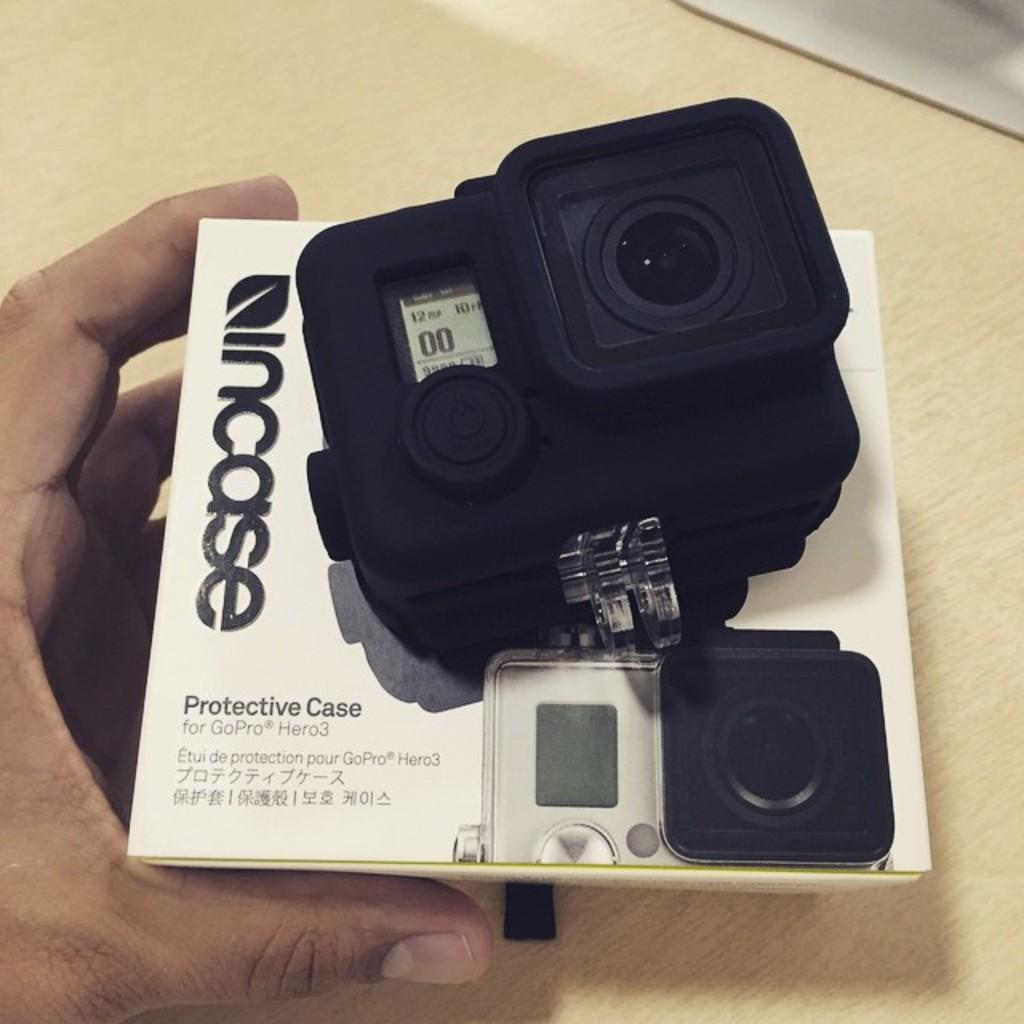Who or what is the main subject in the image? There is a person in the image. What is the person holding in the image? The person is holding a box and a camera. What is the location of the table in the image? There is a table at the bottom of the image. What type of mint is growing on the table in the image? There is no mint present in the image; the table is empty except for the person and the objects they are holding. 